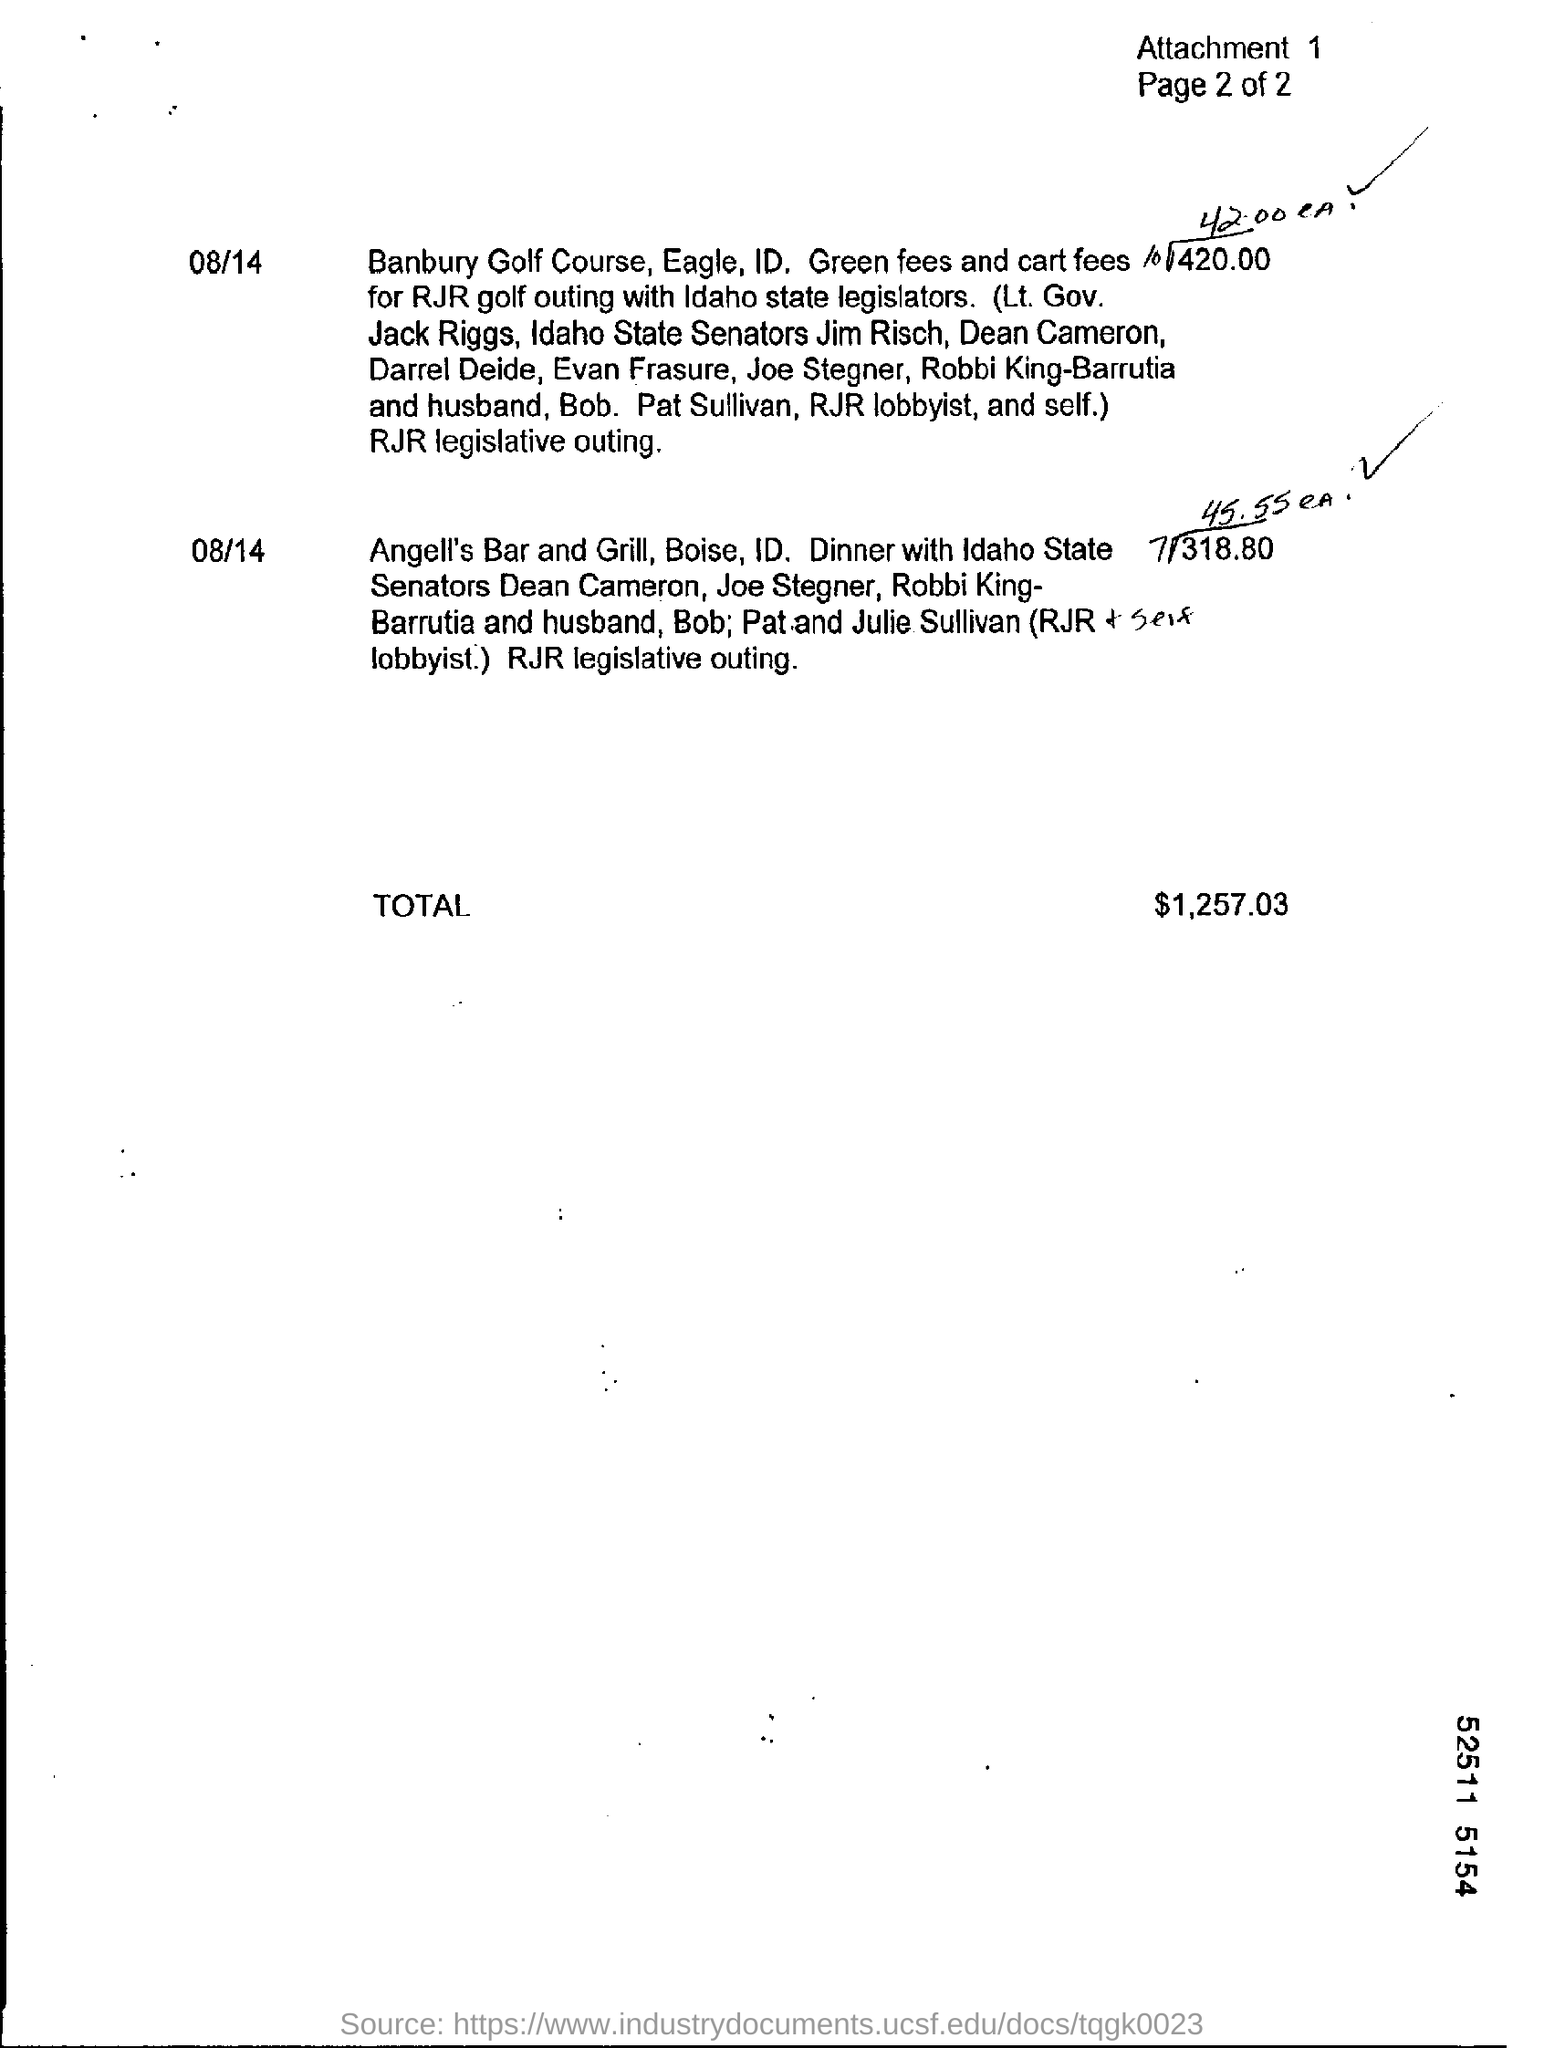Point out several critical features in this image. The total amount is $1,257.03. The number of attachment is 1. 